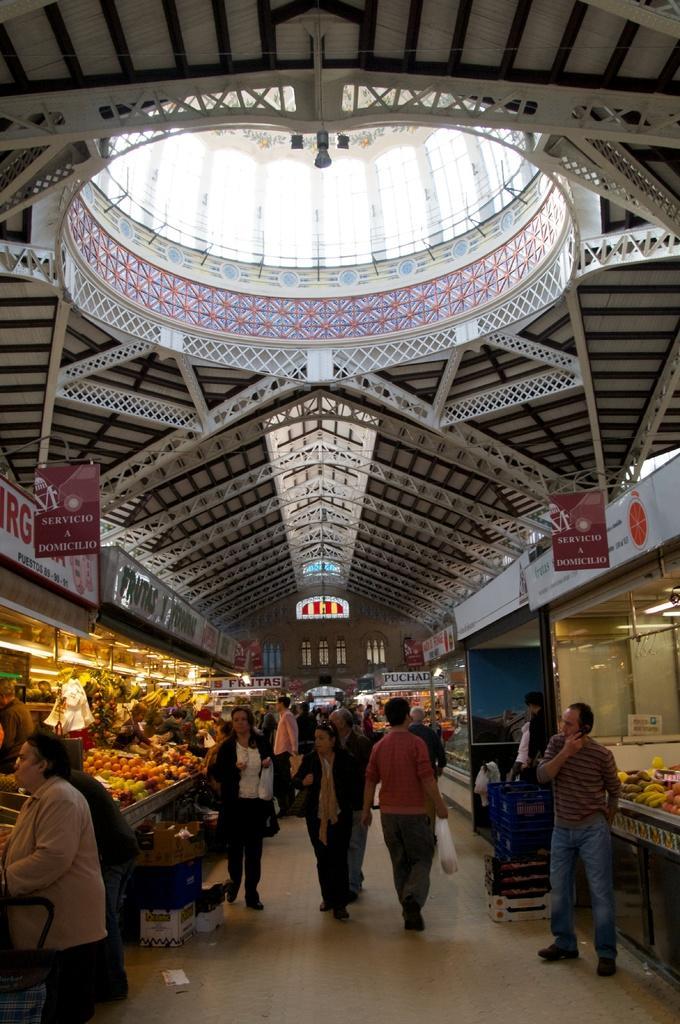Could you give a brief overview of what you see in this image? This image is taken indoors. At the bottom of the image there is a floor. At the top of the image there is a roof and there are many iron bars. On the left and right sides of the image there are many fruits, vegetables and eatables in the baskets. In the middle of the image a few people are walking on the floor and a few are standing. There are a few boards with text on them. 